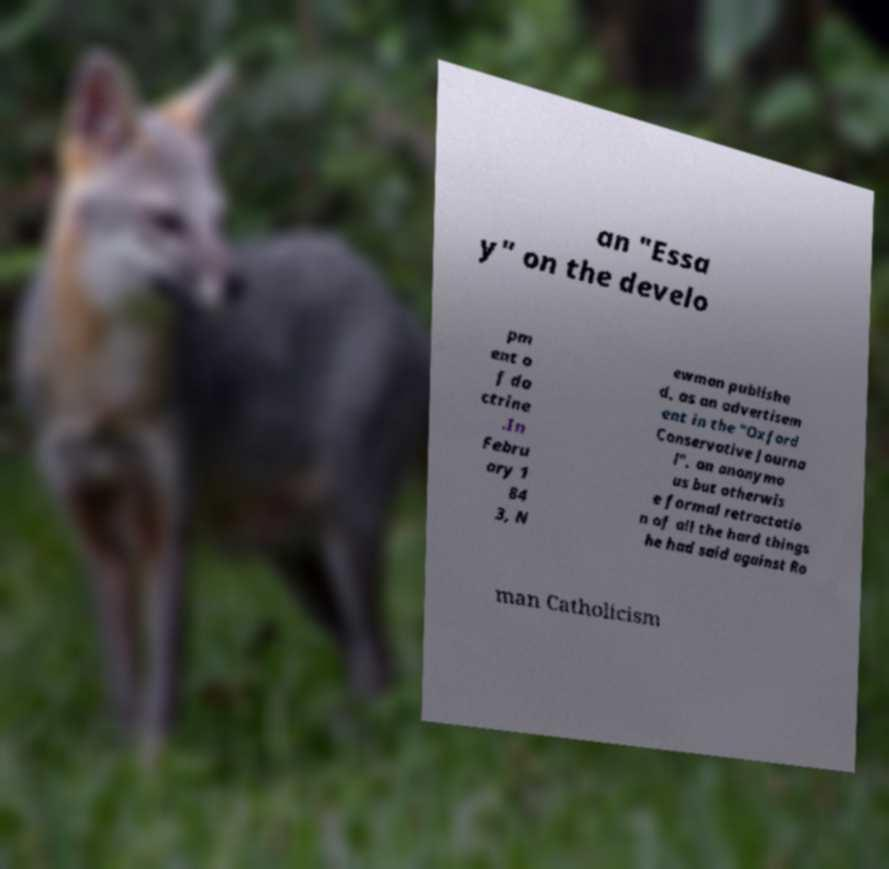I need the written content from this picture converted into text. Can you do that? an "Essa y" on the develo pm ent o f do ctrine .In Febru ary 1 84 3, N ewman publishe d, as an advertisem ent in the "Oxford Conservative Journa l", an anonymo us but otherwis e formal retractatio n of all the hard things he had said against Ro man Catholicism 